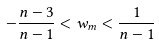Convert formula to latex. <formula><loc_0><loc_0><loc_500><loc_500>- \frac { n - 3 } { n - 1 } < w _ { m } < \frac { 1 } { n - 1 }</formula> 